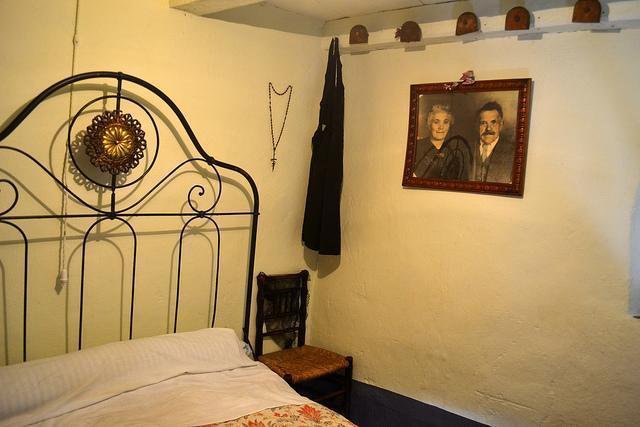How many people in the picture?
Give a very brief answer. 2. How many pictures are on the wall?
Give a very brief answer. 1. How many people are on horseback?
Give a very brief answer. 0. 